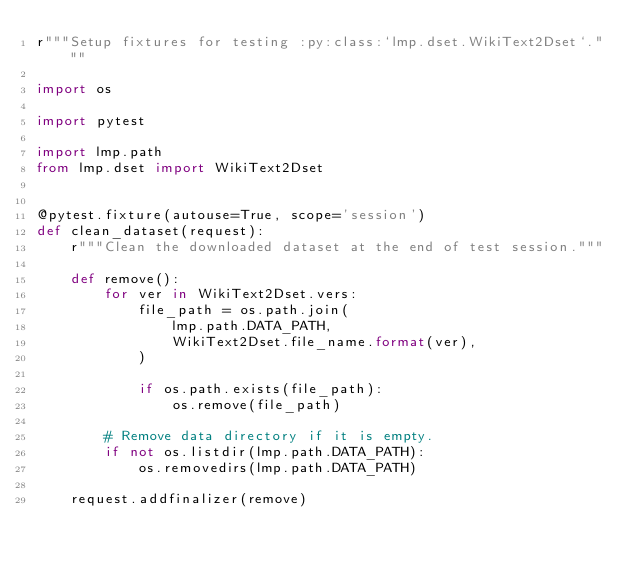<code> <loc_0><loc_0><loc_500><loc_500><_Python_>r"""Setup fixtures for testing :py:class:`lmp.dset.WikiText2Dset`."""

import os

import pytest

import lmp.path
from lmp.dset import WikiText2Dset


@pytest.fixture(autouse=True, scope='session')
def clean_dataset(request):
    r"""Clean the downloaded dataset at the end of test session."""

    def remove():
        for ver in WikiText2Dset.vers:
            file_path = os.path.join(
                lmp.path.DATA_PATH,
                WikiText2Dset.file_name.format(ver),
            )

            if os.path.exists(file_path):
                os.remove(file_path)

        # Remove data directory if it is empty.
        if not os.listdir(lmp.path.DATA_PATH):
            os.removedirs(lmp.path.DATA_PATH)

    request.addfinalizer(remove)
</code> 